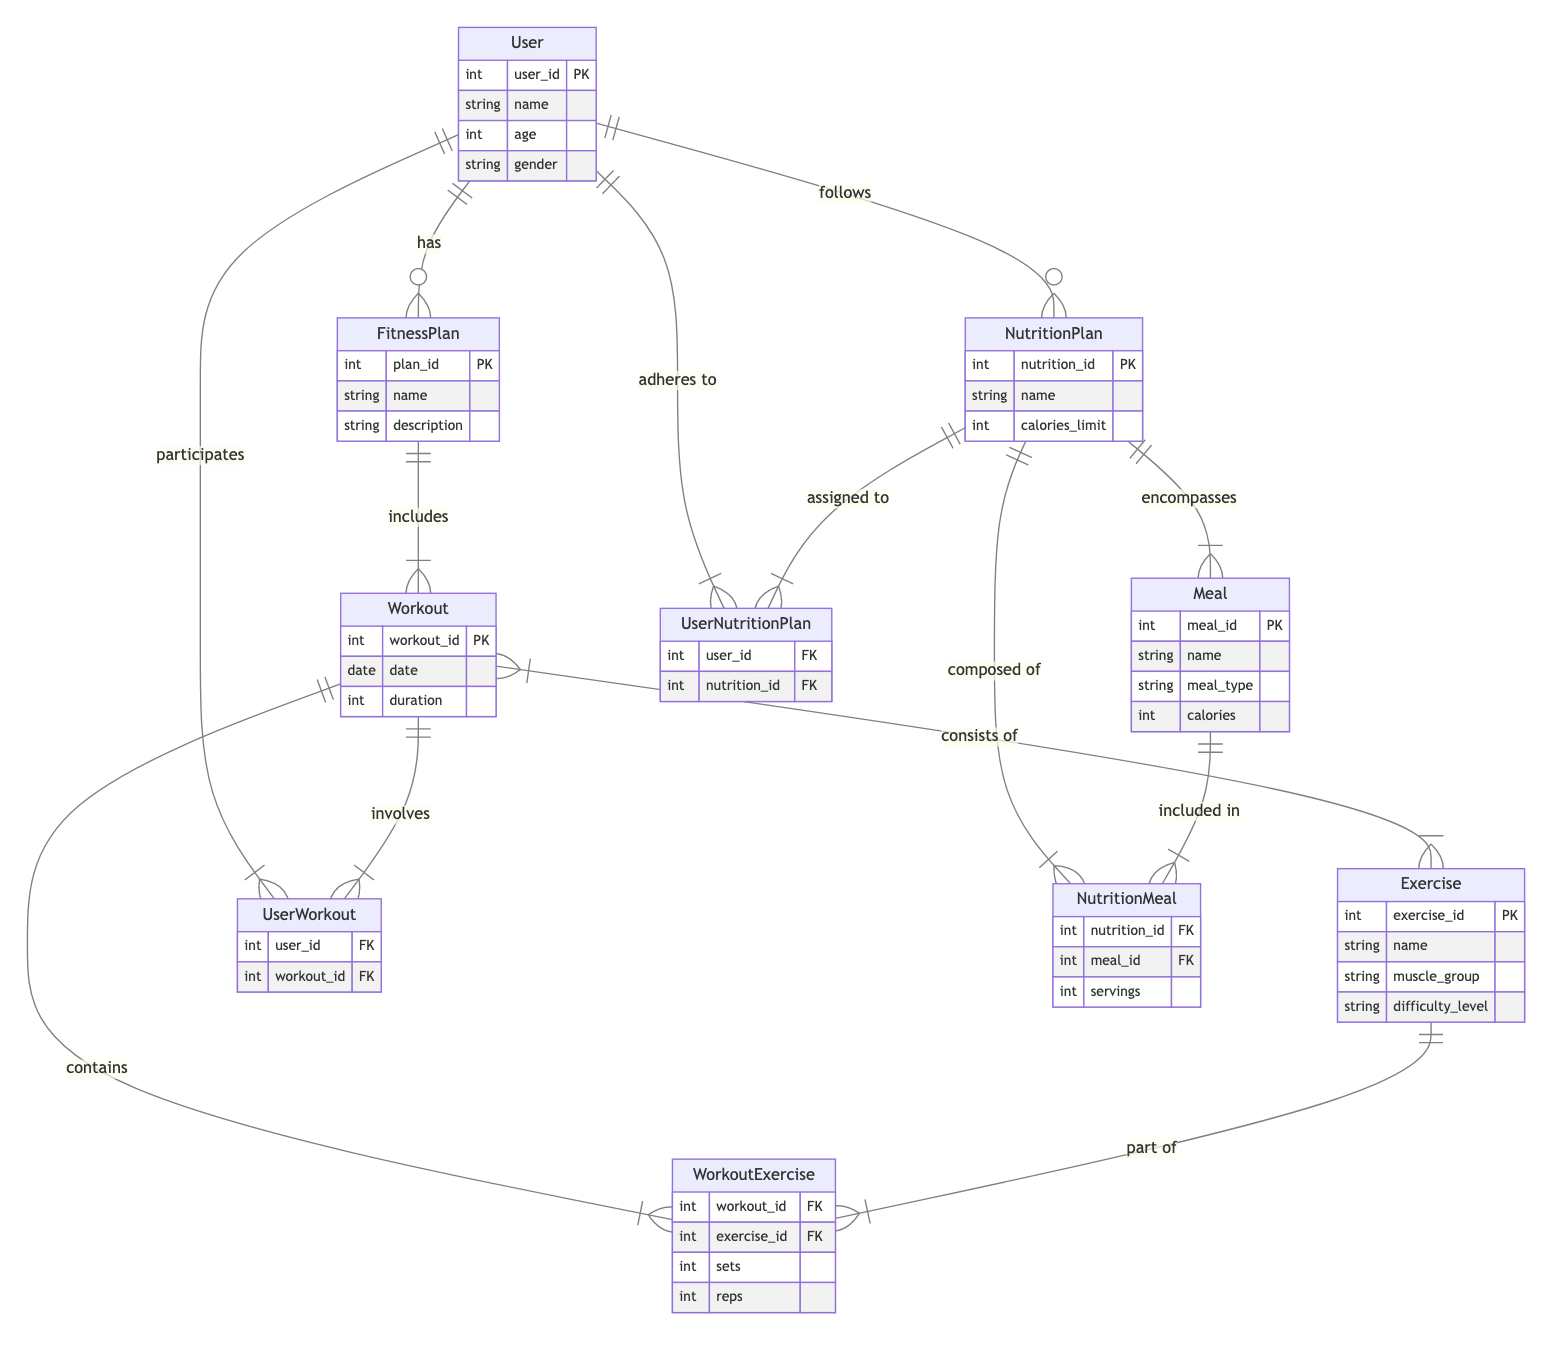What entity has a primary key of user_id? The "User" entity is indicated to have a primary key of user_id as specified in the data section of the diagram.
Answer: User How many attributes does the NutritionPlan entity have? The "NutritionPlan" entity is listed with three attributes: nutrition_id, name, and calories_limit. Thus, it has three attributes.
Answer: Three What relationship exists between User and NutritionPlan? The relationship between "User" and "NutritionPlan" is described as "follows", indicating that users can adopt or adhere to specific nutrition plans.
Answer: Follows Which entity includes the Workout entity? The "FitnessPlan" entity is indicated to include or have the "Workout" entity as part of its structure through the relationship defined as "includes".
Answer: FitnessPlan What does the Workout consist of? The "Workout" entity consists of the "Exercise" entity as indicated by the relationship "consists of". This points out that workouts are composed of specific exercises.
Answer: Exercise How many relationships are established for the User entity? By analyzing the diagram, the "User" entity is involved in multiple relationships: with FitnessPlan, NutritionPlan, UserWorkout, and UserNutritionPlan, totaling four relationships.
Answer: Four Which entity is composed of Meal? The "NutritionPlan" entity is stated to be composed of "Meal" as it encompasses different meal options which fall under the plan.
Answer: NutritionPlan What is the foreign key in the NutritionMeal entity? The "NutritionMeal" entity includes both nutrition_id and meal_id as foreign keys. Therefore, these represent its connections to the associated NutritionPlan and Meal entities.
Answer: Nutrition_id, meal_id Which entity is connected to the WorkoutExercise entity? The "Exercise" entity connects to "WorkoutExercise" through the relationship specified as "part of", indicating that exercises are components of workout sessions.
Answer: Exercise 